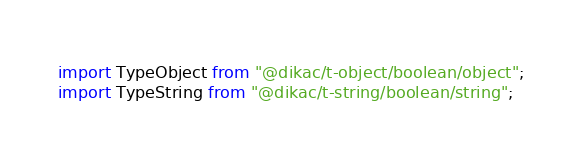<code> <loc_0><loc_0><loc_500><loc_500><_JavaScript_>import TypeObject from "@dikac/t-object/boolean/object";
import TypeString from "@dikac/t-string/boolean/string";</code> 